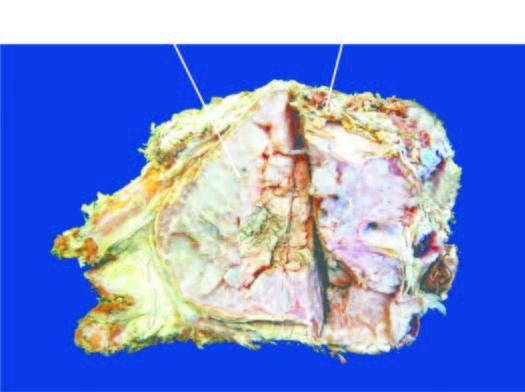does sectioned surface show lobulated mass with bluish cartilaginous hue infiltrating the soft tissues?
Answer the question using a single word or phrase. Yes 